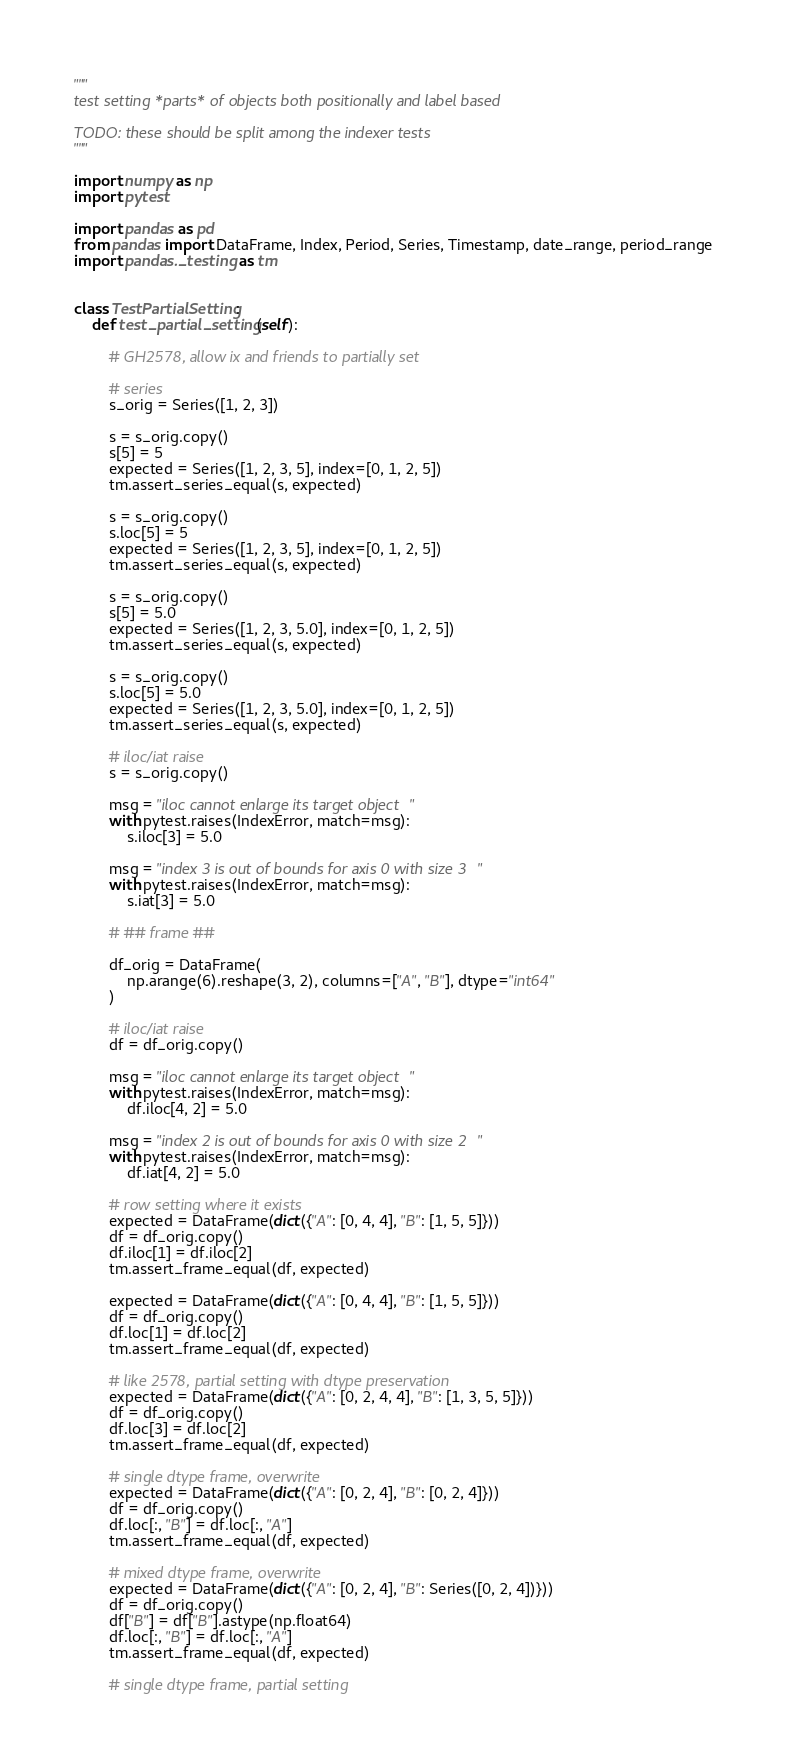Convert code to text. <code><loc_0><loc_0><loc_500><loc_500><_Python_>"""
test setting *parts* of objects both positionally and label based

TODO: these should be split among the indexer tests
"""

import numpy as np
import pytest

import pandas as pd
from pandas import DataFrame, Index, Period, Series, Timestamp, date_range, period_range
import pandas._testing as tm


class TestPartialSetting:
    def test_partial_setting(self):

        # GH2578, allow ix and friends to partially set

        # series
        s_orig = Series([1, 2, 3])

        s = s_orig.copy()
        s[5] = 5
        expected = Series([1, 2, 3, 5], index=[0, 1, 2, 5])
        tm.assert_series_equal(s, expected)

        s = s_orig.copy()
        s.loc[5] = 5
        expected = Series([1, 2, 3, 5], index=[0, 1, 2, 5])
        tm.assert_series_equal(s, expected)

        s = s_orig.copy()
        s[5] = 5.0
        expected = Series([1, 2, 3, 5.0], index=[0, 1, 2, 5])
        tm.assert_series_equal(s, expected)

        s = s_orig.copy()
        s.loc[5] = 5.0
        expected = Series([1, 2, 3, 5.0], index=[0, 1, 2, 5])
        tm.assert_series_equal(s, expected)

        # iloc/iat raise
        s = s_orig.copy()

        msg = "iloc cannot enlarge its target object"
        with pytest.raises(IndexError, match=msg):
            s.iloc[3] = 5.0

        msg = "index 3 is out of bounds for axis 0 with size 3"
        with pytest.raises(IndexError, match=msg):
            s.iat[3] = 5.0

        # ## frame ##

        df_orig = DataFrame(
            np.arange(6).reshape(3, 2), columns=["A", "B"], dtype="int64"
        )

        # iloc/iat raise
        df = df_orig.copy()

        msg = "iloc cannot enlarge its target object"
        with pytest.raises(IndexError, match=msg):
            df.iloc[4, 2] = 5.0

        msg = "index 2 is out of bounds for axis 0 with size 2"
        with pytest.raises(IndexError, match=msg):
            df.iat[4, 2] = 5.0

        # row setting where it exists
        expected = DataFrame(dict({"A": [0, 4, 4], "B": [1, 5, 5]}))
        df = df_orig.copy()
        df.iloc[1] = df.iloc[2]
        tm.assert_frame_equal(df, expected)

        expected = DataFrame(dict({"A": [0, 4, 4], "B": [1, 5, 5]}))
        df = df_orig.copy()
        df.loc[1] = df.loc[2]
        tm.assert_frame_equal(df, expected)

        # like 2578, partial setting with dtype preservation
        expected = DataFrame(dict({"A": [0, 2, 4, 4], "B": [1, 3, 5, 5]}))
        df = df_orig.copy()
        df.loc[3] = df.loc[2]
        tm.assert_frame_equal(df, expected)

        # single dtype frame, overwrite
        expected = DataFrame(dict({"A": [0, 2, 4], "B": [0, 2, 4]}))
        df = df_orig.copy()
        df.loc[:, "B"] = df.loc[:, "A"]
        tm.assert_frame_equal(df, expected)

        # mixed dtype frame, overwrite
        expected = DataFrame(dict({"A": [0, 2, 4], "B": Series([0, 2, 4])}))
        df = df_orig.copy()
        df["B"] = df["B"].astype(np.float64)
        df.loc[:, "B"] = df.loc[:, "A"]
        tm.assert_frame_equal(df, expected)

        # single dtype frame, partial setting</code> 